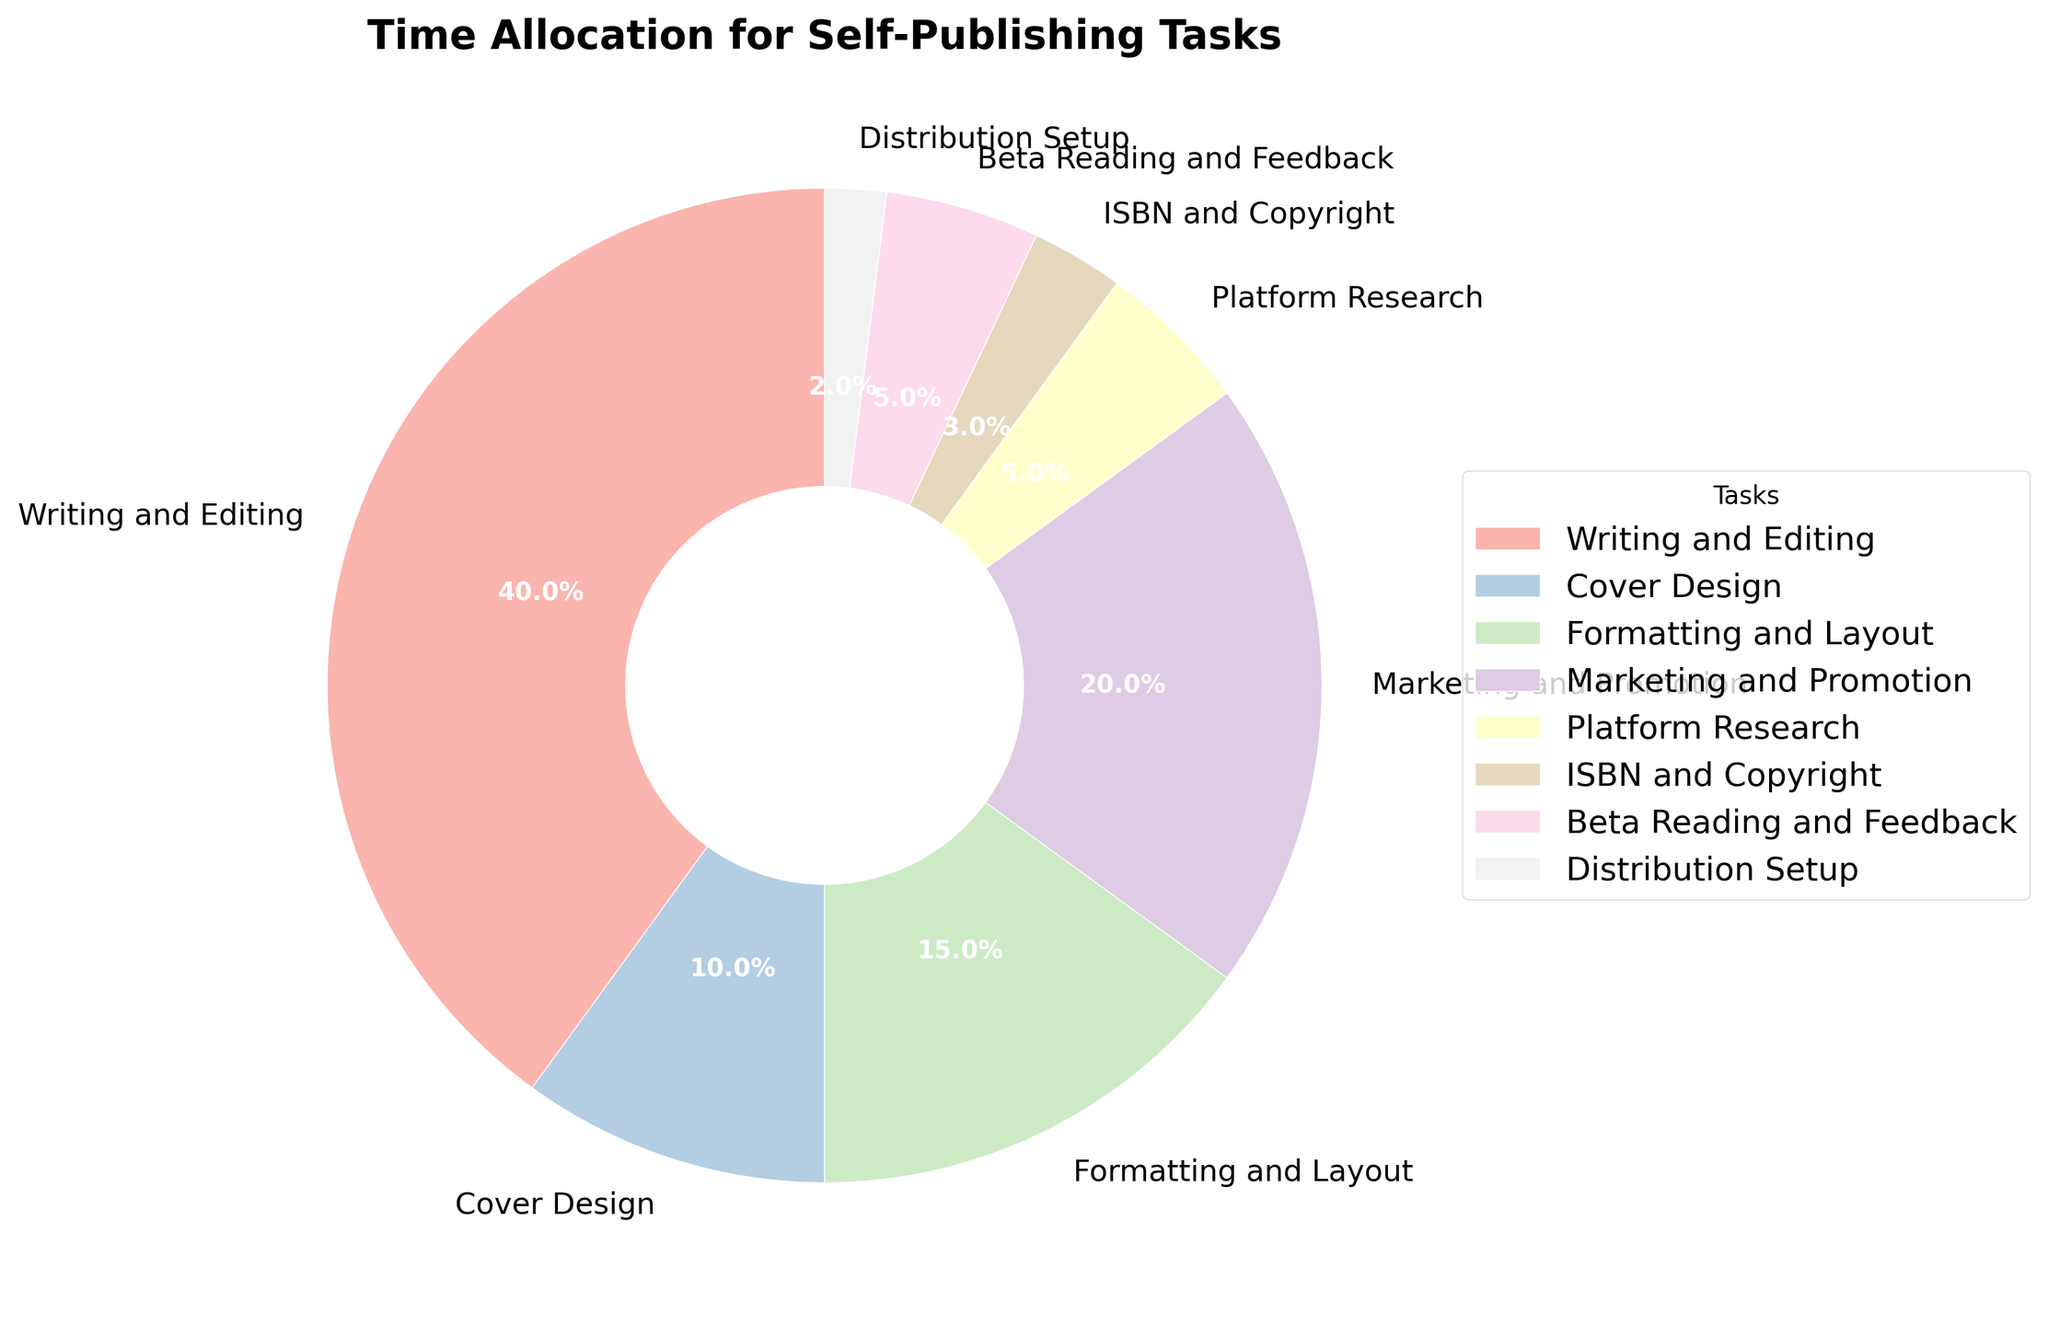What task takes up the most time in the self-publishing process? The pie chart shows that "Writing and Editing" has the largest portion.
Answer: Writing and Editing Which tasks together take up a smaller percentage than Marketing and Promotion? Add the percentages of the tasks smaller than Marketing and Promotion: (Platform Research + ISBN and Copyright + Beta Reading and Feedback + Distribution Setup) = (5% + 3% + 5% + 2%) = 15%, which is less than Marketing and Promotion (20%).
Answer: Platform Research, ISBN and Copyright, Beta Reading and Feedback, Distribution Setup How much more time is spent on Writing and Editing than on Cover Design? Subtract the percentage of Cover Design from the percentage of Writing and Editing: 40% - 10% = 30%.
Answer: 30% Which two tasks have the smallest time allocation? The chart shows "Distribution Setup" and "ISBN and Copyright" have the smallest sections.
Answer: Distribution Setup and ISBN and Copyright Is there any task that occupies exactly 15% of the time? Check the percentage values in the pie chart and verify that "Formatting and Layout" is assigned 15%.
Answer: Yes, Formatting and Layout What tasks combined make up exactly half of the total time? Combine the tasks to check if their percentages sum to 50%: "Writing and Editing" (40%) + "Formatting and Layout" (15%) is more than 50%, so check alternatives. "Marketing and Promotion" (20%) + "Cover Design" (10%) + "Formatting and Layout" (15%) + "Platform Research" (5%) = 50%.
Answer: Marketing and Promotion, Cover Design, Formatting and Layout, Platform Research Between Marketing and Promotion, and Beta Reading and Feedback, which one takes up more time and by how much? Subtract the percentage of Beta Reading and Feedback from Marketing and Promotion: 20% - 5% = 15%.
Answer: Marketing and Promotion by 15% What percentage of time is allocated to tasks related to the final steps of the publishing process (i.e., after writing has been completed)? Add the percentages of tasks after Writing and Editing: (Cover Design + Formatting and Layout + Marketing and Promotion + Platform Research + ISBN and Copyright + Beta Reading and Feedback + Distribution Setup) = (10% + 15% + 20% + 5% + 3% + 5% + 2%) = 60%.
Answer: 60% What's the difference in time allocation between the task with the smallest percentage and the task with the largest percentage? Subtract the smallest percentage (2%) from the largest percentage (40%): 40% - 2% = 38%.
Answer: 38% 